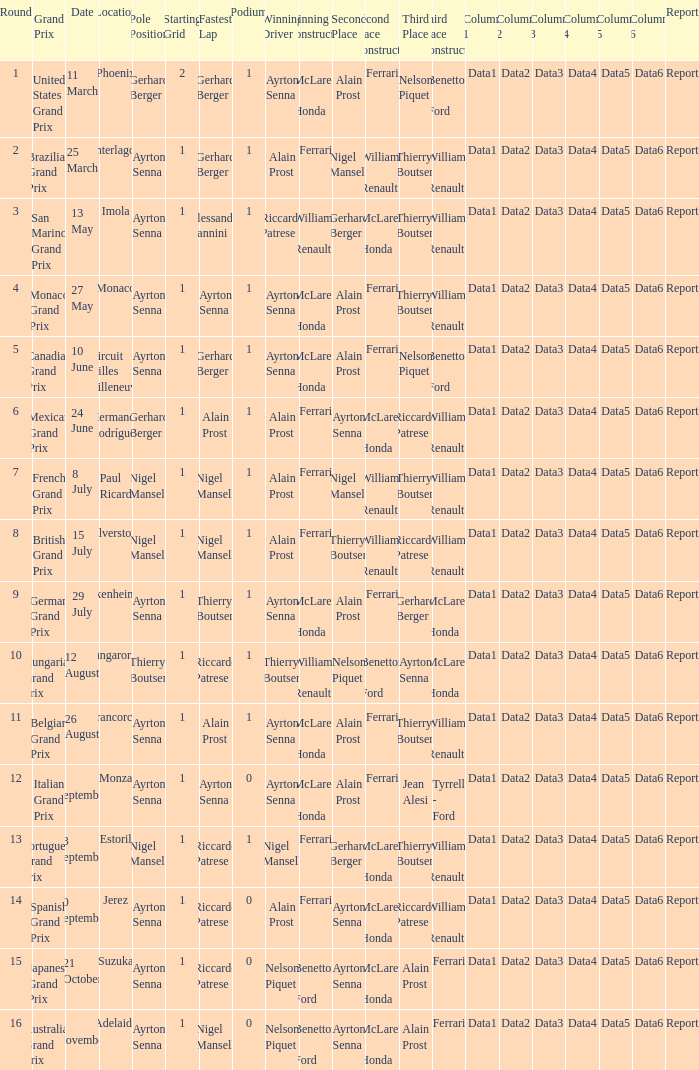What is the Pole Position for the German Grand Prix Ayrton Senna. 